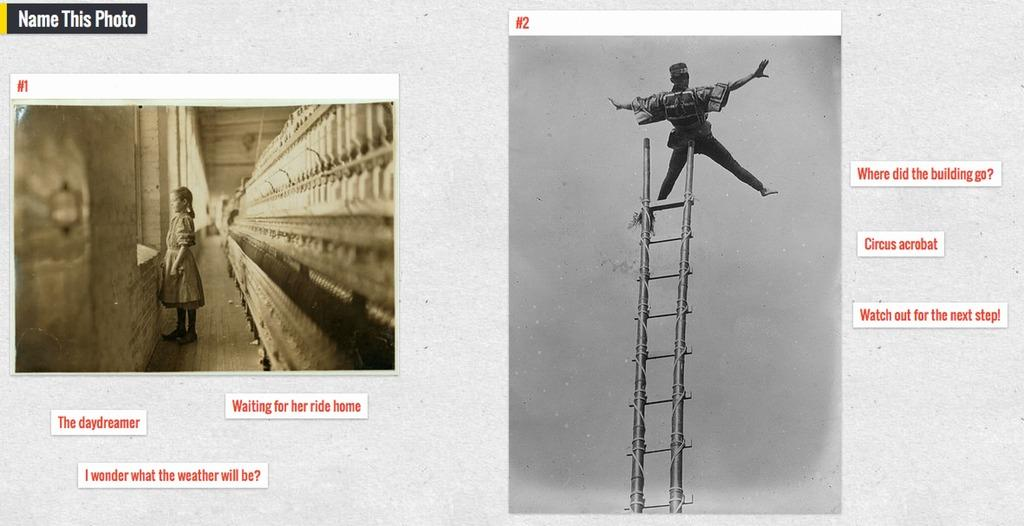<image>
Write a terse but informative summary of the picture. A name this photo game consists of two photographs. 